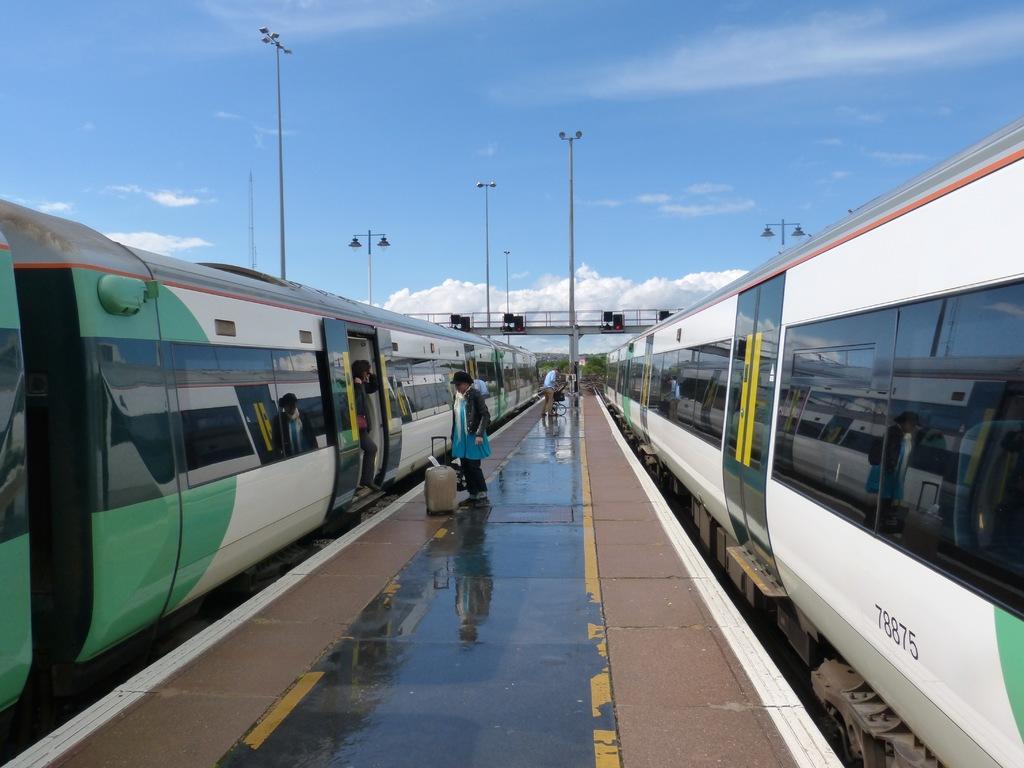In one or two sentences, can you explain what this image depicts? In the image we can see there are people standing on the footpath and on the both the sides there are trains standing on the railway tracks. 